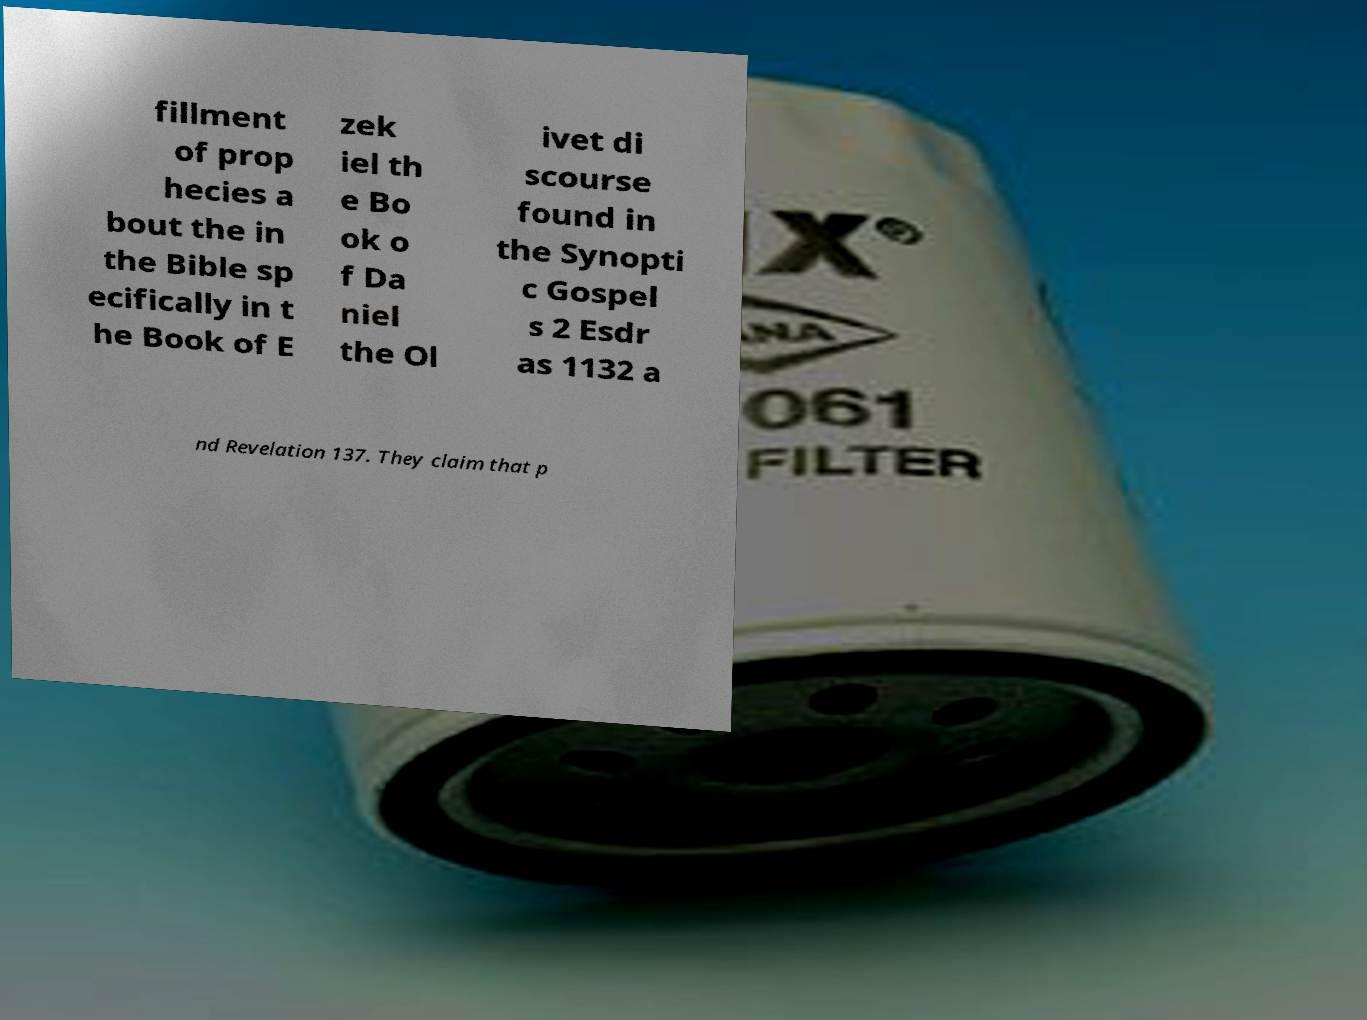Please identify and transcribe the text found in this image. fillment of prop hecies a bout the in the Bible sp ecifically in t he Book of E zek iel th e Bo ok o f Da niel the Ol ivet di scourse found in the Synopti c Gospel s 2 Esdr as 1132 a nd Revelation 137. They claim that p 